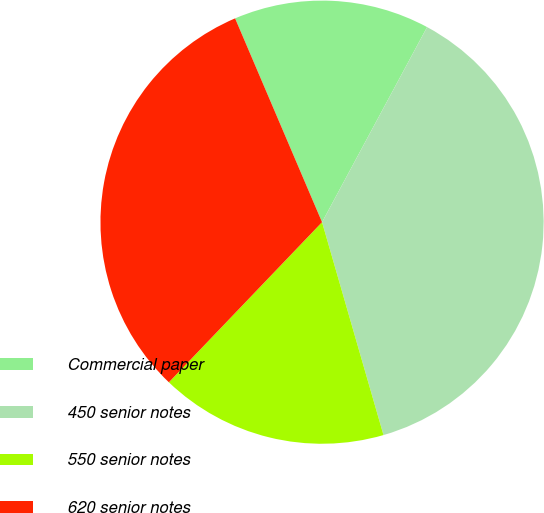<chart> <loc_0><loc_0><loc_500><loc_500><pie_chart><fcel>Commercial paper<fcel>450 senior notes<fcel>550 senior notes<fcel>620 senior notes<nl><fcel>14.28%<fcel>37.67%<fcel>16.62%<fcel>31.44%<nl></chart> 